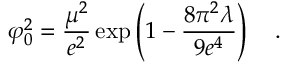<formula> <loc_0><loc_0><loc_500><loc_500>\varphi _ { 0 } ^ { 2 } = { \frac { \mu ^ { 2 } } { e ^ { 2 } } } \exp \left ( 1 - { \frac { 8 \pi ^ { 2 } \lambda } { 9 e ^ { 4 } } } \right ) .</formula> 